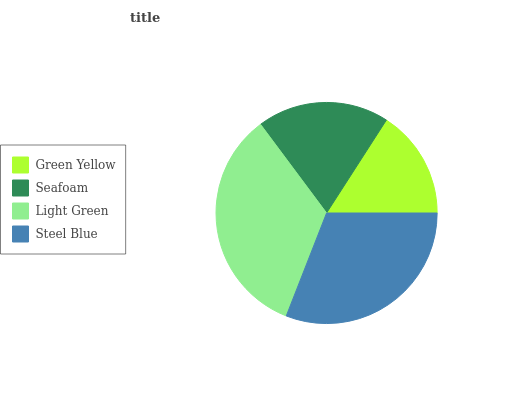Is Green Yellow the minimum?
Answer yes or no. Yes. Is Light Green the maximum?
Answer yes or no. Yes. Is Seafoam the minimum?
Answer yes or no. No. Is Seafoam the maximum?
Answer yes or no. No. Is Seafoam greater than Green Yellow?
Answer yes or no. Yes. Is Green Yellow less than Seafoam?
Answer yes or no. Yes. Is Green Yellow greater than Seafoam?
Answer yes or no. No. Is Seafoam less than Green Yellow?
Answer yes or no. No. Is Steel Blue the high median?
Answer yes or no. Yes. Is Seafoam the low median?
Answer yes or no. Yes. Is Light Green the high median?
Answer yes or no. No. Is Light Green the low median?
Answer yes or no. No. 